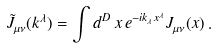Convert formula to latex. <formula><loc_0><loc_0><loc_500><loc_500>\tilde { J } _ { \mu \nu } ( k ^ { \lambda } ) = \int d ^ { D } \, x \, e ^ { - i k _ { \lambda } x ^ { \lambda } } J _ { \mu \nu } ( x ) \, .</formula> 